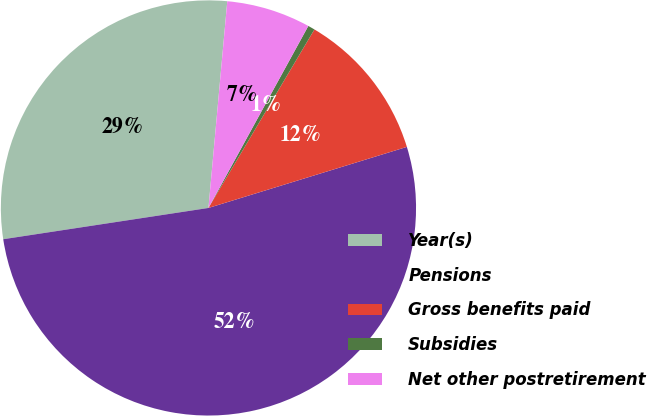Convert chart. <chart><loc_0><loc_0><loc_500><loc_500><pie_chart><fcel>Year(s)<fcel>Pensions<fcel>Gross benefits paid<fcel>Subsidies<fcel>Net other postretirement<nl><fcel>28.85%<fcel>52.34%<fcel>11.72%<fcel>0.54%<fcel>6.54%<nl></chart> 